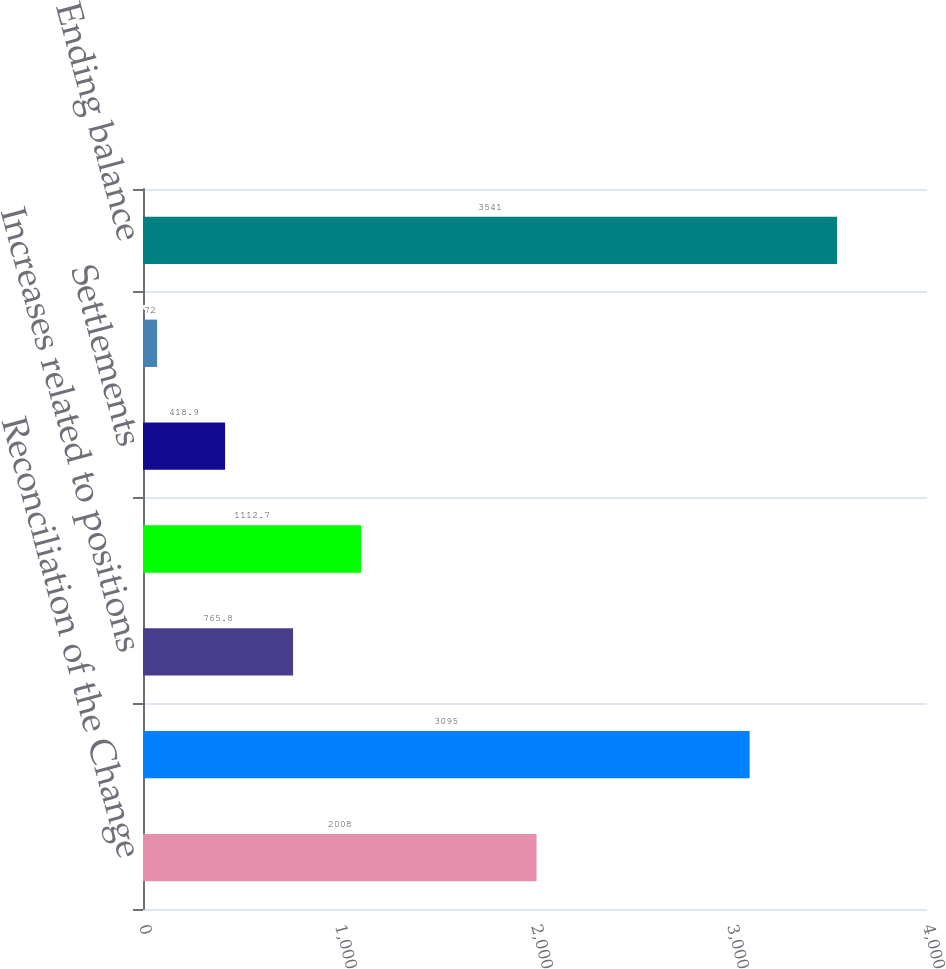<chart> <loc_0><loc_0><loc_500><loc_500><bar_chart><fcel>Reconciliation of the Change<fcel>Beginning balance<fcel>Increases related to positions<fcel>Decreases related to positions<fcel>Settlements<fcel>Expiration of statute of<fcel>Ending balance<nl><fcel>2008<fcel>3095<fcel>765.8<fcel>1112.7<fcel>418.9<fcel>72<fcel>3541<nl></chart> 